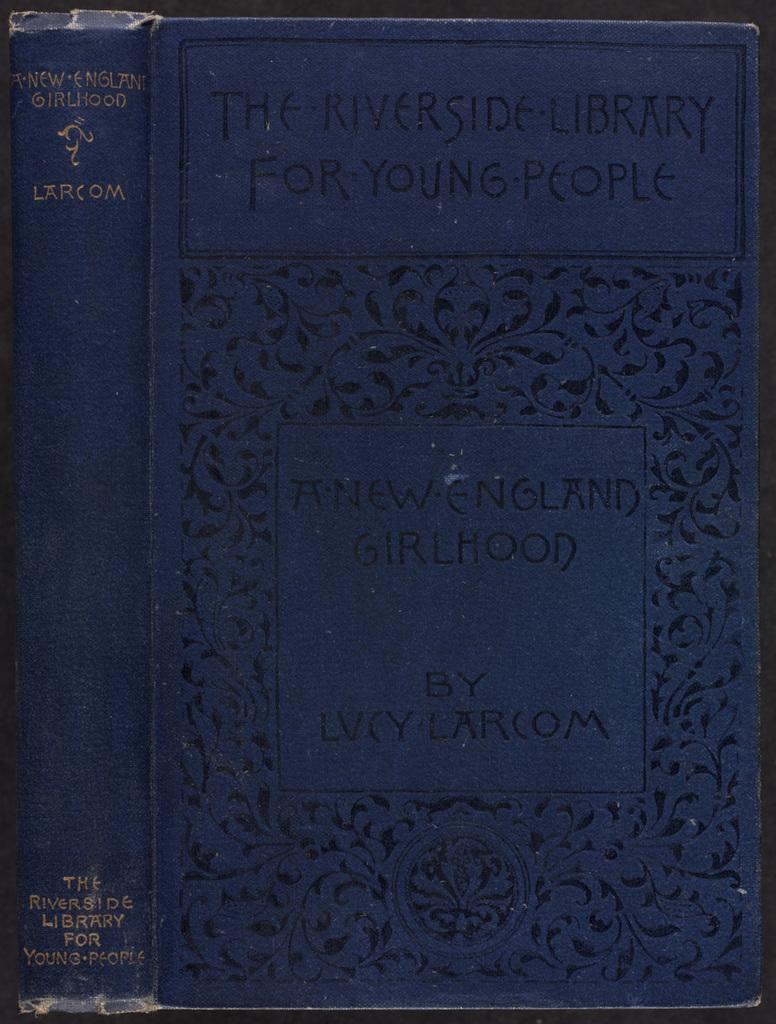Is this for young people?
Offer a very short reply. Yes. What is the name of the book?
Your answer should be very brief. A new england girlhood. 